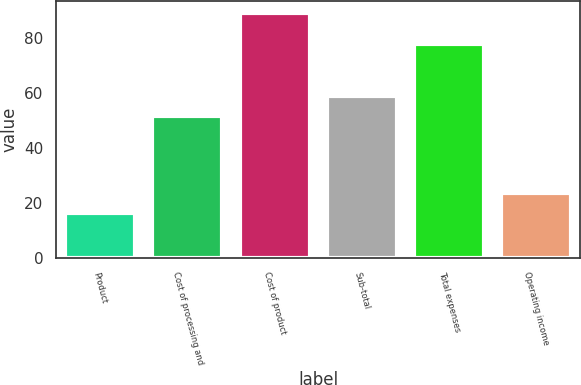Convert chart. <chart><loc_0><loc_0><loc_500><loc_500><bar_chart><fcel>Product<fcel>Cost of processing and<fcel>Cost of product<fcel>Sub-total<fcel>Total expenses<fcel>Operating income<nl><fcel>16.2<fcel>51.6<fcel>89.2<fcel>58.9<fcel>78<fcel>23.5<nl></chart> 